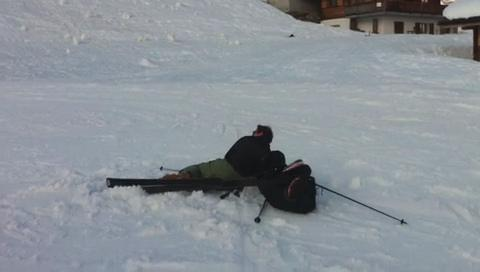What happened to this person? they fell 